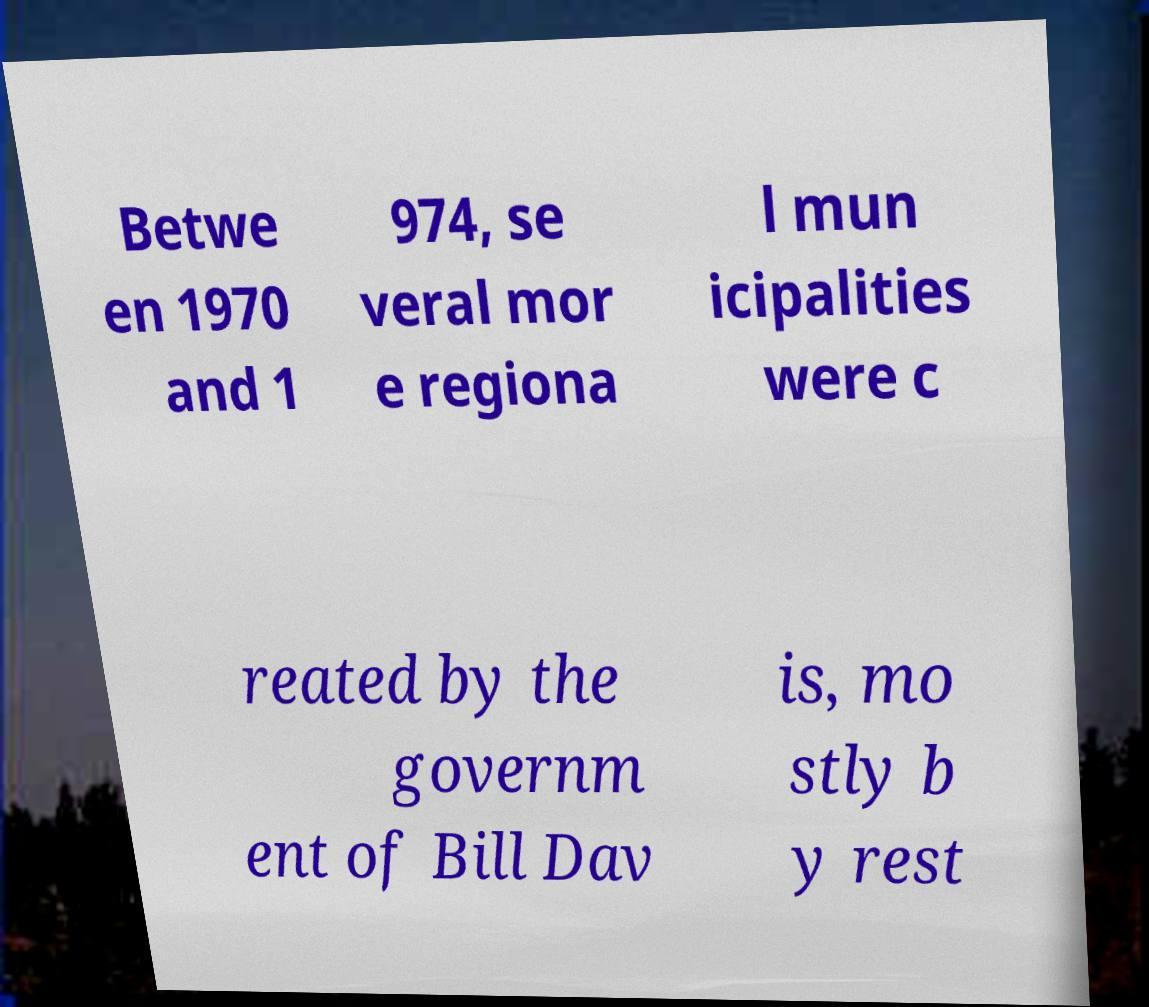Can you read and provide the text displayed in the image?This photo seems to have some interesting text. Can you extract and type it out for me? Betwe en 1970 and 1 974, se veral mor e regiona l mun icipalities were c reated by the governm ent of Bill Dav is, mo stly b y rest 